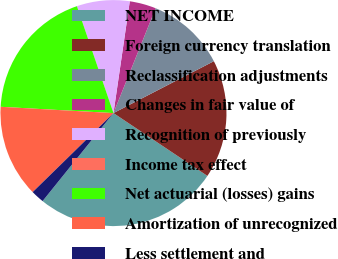Convert chart to OTSL. <chart><loc_0><loc_0><loc_500><loc_500><pie_chart><fcel>NET INCOME<fcel>Foreign currency translation<fcel>Reclassification adjustments<fcel>Changes in fair value of<fcel>Recognition of previously<fcel>Income tax effect<fcel>Net actuarial (losses) gains<fcel>Amortization of unrecognized<fcel>Less settlement and<nl><fcel>26.41%<fcel>16.98%<fcel>11.32%<fcel>3.78%<fcel>7.55%<fcel>0.0%<fcel>18.87%<fcel>13.21%<fcel>1.89%<nl></chart> 